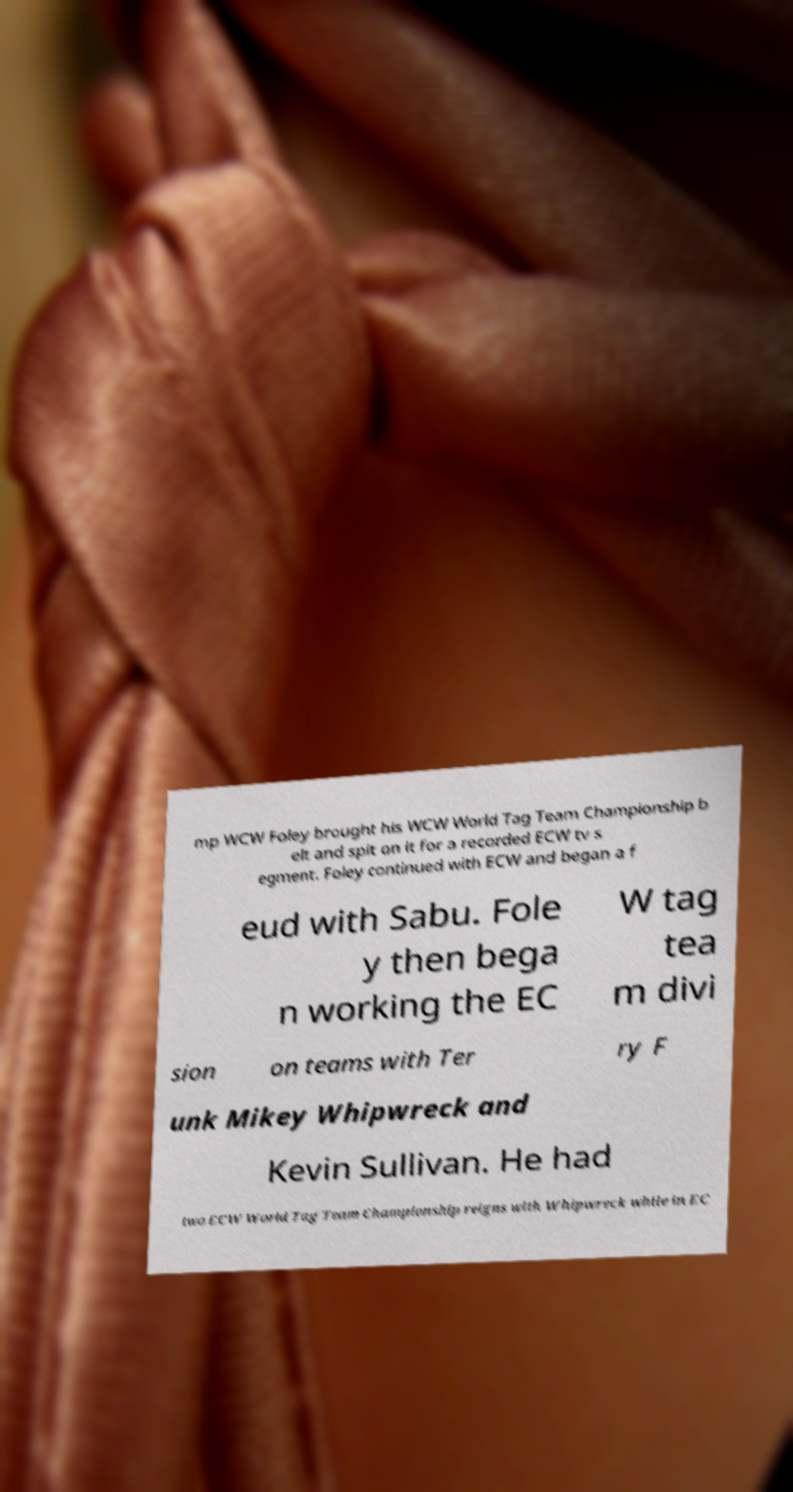There's text embedded in this image that I need extracted. Can you transcribe it verbatim? mp WCW Foley brought his WCW World Tag Team Championship b elt and spit on it for a recorded ECW tv s egment. Foley continued with ECW and began a f eud with Sabu. Fole y then bega n working the EC W tag tea m divi sion on teams with Ter ry F unk Mikey Whipwreck and Kevin Sullivan. He had two ECW World Tag Team Championship reigns with Whipwreck while in EC 